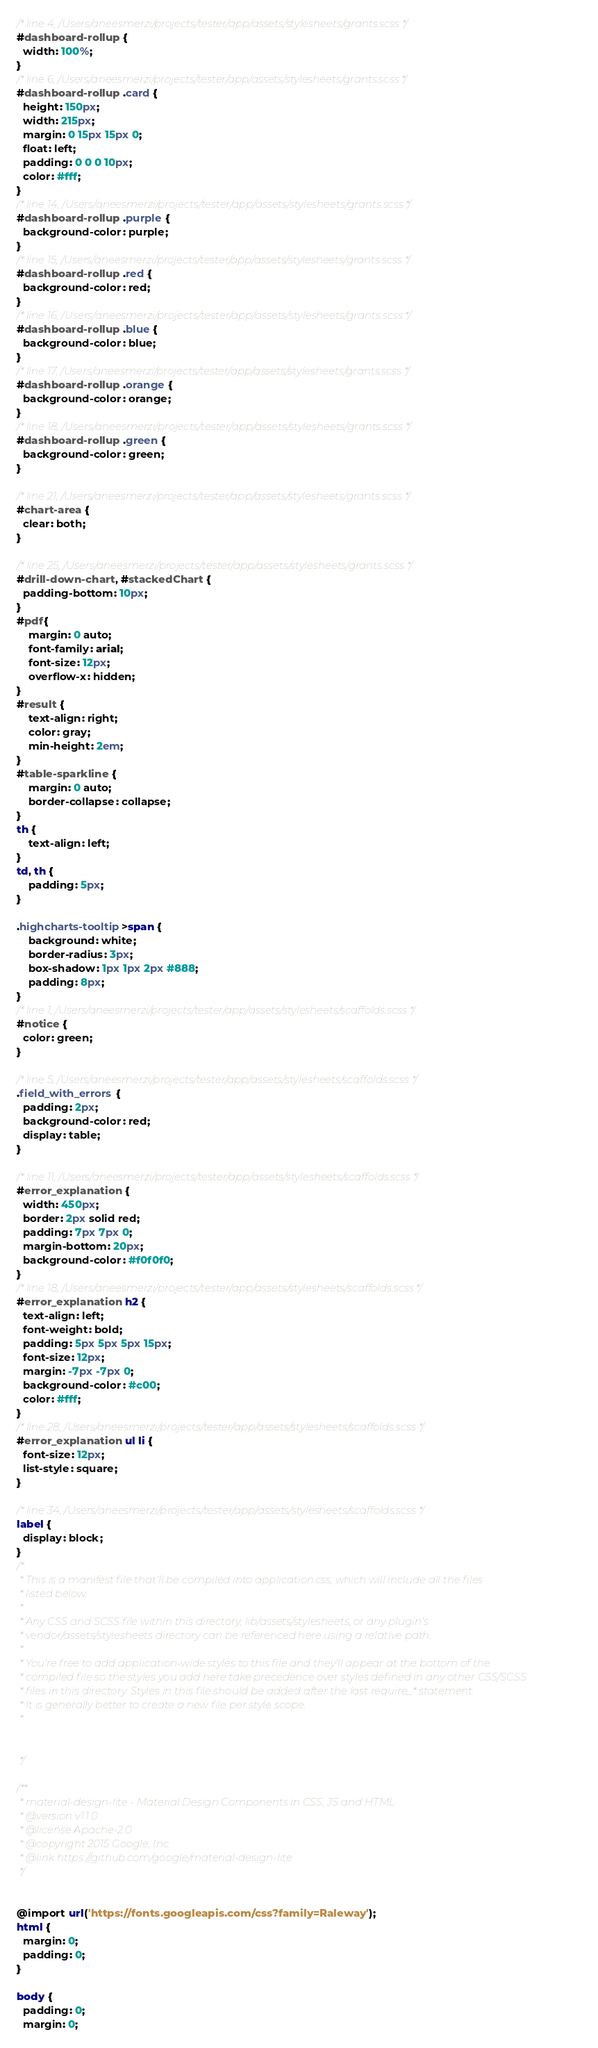Convert code to text. <code><loc_0><loc_0><loc_500><loc_500><_CSS_>/* line 4, /Users/aneesmerzi/projects/tester/app/assets/stylesheets/grants.scss */
#dashboard-rollup {
  width: 100%;
}
/* line 6, /Users/aneesmerzi/projects/tester/app/assets/stylesheets/grants.scss */
#dashboard-rollup .card {
  height: 150px;
  width: 215px;
  margin: 0 15px 15px 0;
  float: left;
  padding: 0 0 0 10px;
  color: #fff;
}
/* line 14, /Users/aneesmerzi/projects/tester/app/assets/stylesheets/grants.scss */
#dashboard-rollup .purple {
  background-color: purple;
}
/* line 15, /Users/aneesmerzi/projects/tester/app/assets/stylesheets/grants.scss */
#dashboard-rollup .red {
  background-color: red;
}
/* line 16, /Users/aneesmerzi/projects/tester/app/assets/stylesheets/grants.scss */
#dashboard-rollup .blue {
  background-color: blue;
}
/* line 17, /Users/aneesmerzi/projects/tester/app/assets/stylesheets/grants.scss */
#dashboard-rollup .orange {
  background-color: orange;
}
/* line 18, /Users/aneesmerzi/projects/tester/app/assets/stylesheets/grants.scss */
#dashboard-rollup .green {
  background-color: green;
}

/* line 21, /Users/aneesmerzi/projects/tester/app/assets/stylesheets/grants.scss */
#chart-area {
  clear: both;
}

/* line 25, /Users/aneesmerzi/projects/tester/app/assets/stylesheets/grants.scss */
#drill-down-chart, #stackedChart {
  padding-bottom: 10px;
}
#pdf{
	margin: 0 auto;
	font-family: arial;
	font-size: 12px;
	overflow-x: hidden;
}
#result {
    text-align: right;
    color: gray;
    min-height: 2em;
}
#table-sparkline {
    margin: 0 auto;
    border-collapse: collapse;
}
th {
    text-align: left;
}
td, th {
    padding: 5px;
}

.highcharts-tooltip>span {
    background: white;
    border-radius: 3px;
    box-shadow: 1px 1px 2px #888;
    padding: 8px;
}
/* line 1, /Users/aneesmerzi/projects/tester/app/assets/stylesheets/scaffolds.scss */
#notice {
  color: green;
}

/* line 5, /Users/aneesmerzi/projects/tester/app/assets/stylesheets/scaffolds.scss */
.field_with_errors {
  padding: 2px;
  background-color: red;
  display: table;
}

/* line 11, /Users/aneesmerzi/projects/tester/app/assets/stylesheets/scaffolds.scss */
#error_explanation {
  width: 450px;
  border: 2px solid red;
  padding: 7px 7px 0;
  margin-bottom: 20px;
  background-color: #f0f0f0;
}
/* line 18, /Users/aneesmerzi/projects/tester/app/assets/stylesheets/scaffolds.scss */
#error_explanation h2 {
  text-align: left;
  font-weight: bold;
  padding: 5px 5px 5px 15px;
  font-size: 12px;
  margin: -7px -7px 0;
  background-color: #c00;
  color: #fff;
}
/* line 28, /Users/aneesmerzi/projects/tester/app/assets/stylesheets/scaffolds.scss */
#error_explanation ul li {
  font-size: 12px;
  list-style: square;
}

/* line 34, /Users/aneesmerzi/projects/tester/app/assets/stylesheets/scaffolds.scss */
label {
  display: block;
}
/*
 * This is a manifest file that'll be compiled into application.css, which will include all the files
 * listed below.
 *
 * Any CSS and SCSS file within this directory, lib/assets/stylesheets, or any plugin's
 * vendor/assets/stylesheets directory can be referenced here using a relative path.
 *
 * You're free to add application-wide styles to this file and they'll appear at the bottom of the
 * compiled file so the styles you add here take precedence over styles defined in any other CSS/SCSS
 * files in this directory. Styles in this file should be added after the last require_* statement.
 * It is generally better to create a new file per style scope.
 *


 */

/**
 * material-design-lite - Material Design Components in CSS, JS and HTML
 * @version v1.1.0
 * @license Apache-2.0
 * @copyright 2015 Google, Inc.
 * @link https://github.com/google/material-design-lite
 */


@import url('https://fonts.googleapis.com/css?family=Raleway');
html {
  margin: 0;
  padding: 0;
}

body {
  padding: 0;
  margin: 0;</code> 